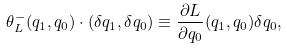Convert formula to latex. <formula><loc_0><loc_0><loc_500><loc_500>\theta _ { L } ^ { - } ( q _ { 1 } , q _ { 0 } ) \cdot ( \delta q _ { 1 } , \delta q _ { 0 } ) \equiv \frac { \partial L } { \partial q _ { 0 } } ( q _ { 1 } , q _ { 0 } ) \delta q _ { 0 } ,</formula> 